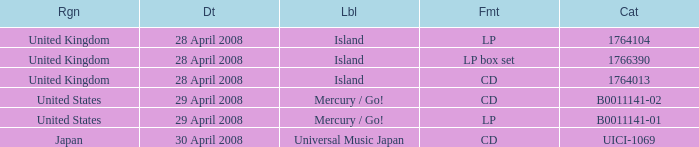What is the Label of the B0011141-01 Catalog? Mercury / Go!. 